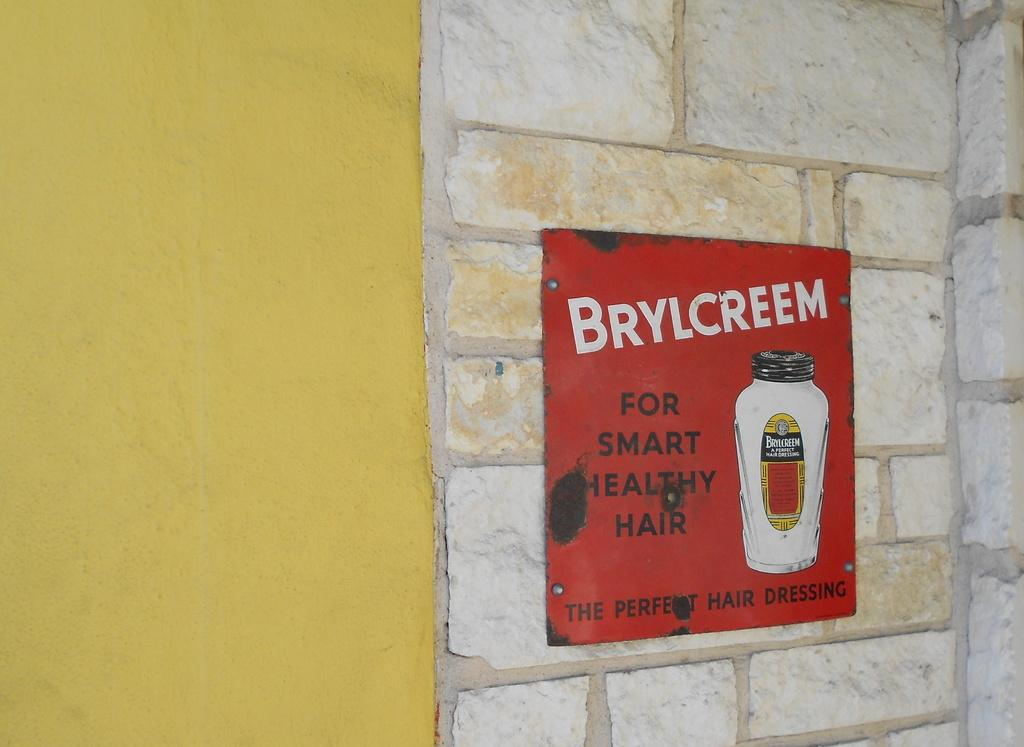<image>
Offer a succinct explanation of the picture presented. You must use this product if you want healthy hair. 